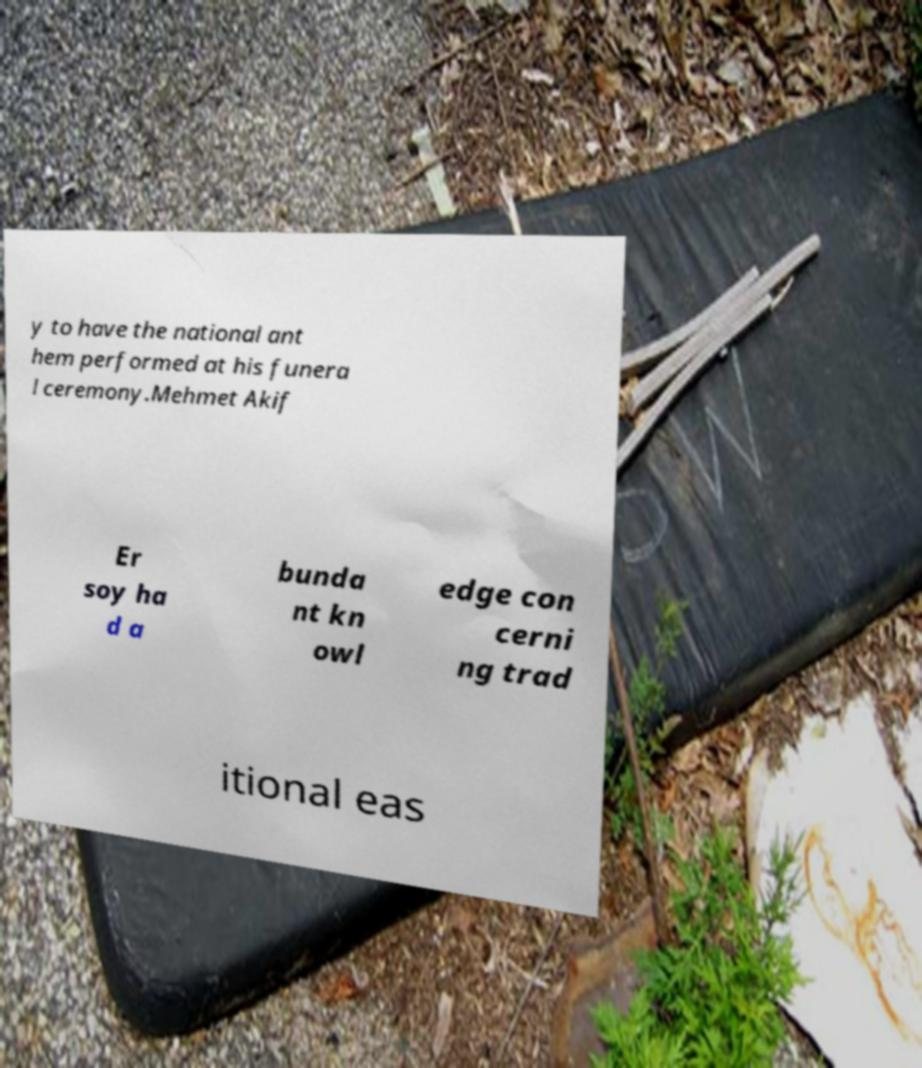Could you assist in decoding the text presented in this image and type it out clearly? y to have the national ant hem performed at his funera l ceremony.Mehmet Akif Er soy ha d a bunda nt kn owl edge con cerni ng trad itional eas 